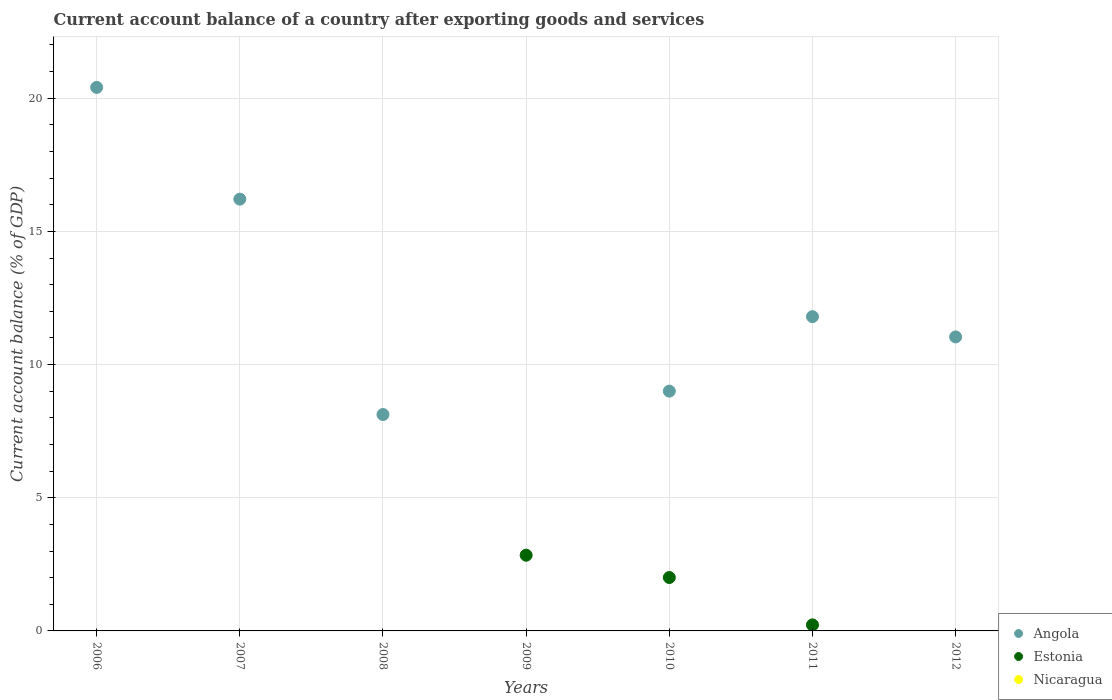Is the number of dotlines equal to the number of legend labels?
Your answer should be very brief. No. What is the account balance in Estonia in 2009?
Your answer should be compact. 2.84. Across all years, what is the maximum account balance in Estonia?
Keep it short and to the point. 2.84. Across all years, what is the minimum account balance in Nicaragua?
Offer a very short reply. 0. In which year was the account balance in Estonia maximum?
Ensure brevity in your answer.  2009. What is the total account balance in Angola in the graph?
Your answer should be very brief. 76.59. What is the difference between the account balance in Angola in 2007 and that in 2008?
Provide a succinct answer. 8.09. What is the difference between the account balance in Nicaragua in 2007 and the account balance in Estonia in 2012?
Keep it short and to the point. 0. What is the average account balance in Estonia per year?
Provide a succinct answer. 0.72. In the year 2011, what is the difference between the account balance in Estonia and account balance in Angola?
Offer a very short reply. -11.57. What is the ratio of the account balance in Estonia in 2009 to that in 2010?
Make the answer very short. 1.42. Is the account balance in Estonia in 2009 less than that in 2011?
Provide a succinct answer. No. What is the difference between the highest and the second highest account balance in Estonia?
Provide a short and direct response. 0.84. What is the difference between the highest and the lowest account balance in Estonia?
Your response must be concise. 2.84. Is the sum of the account balance in Angola in 2007 and 2010 greater than the maximum account balance in Estonia across all years?
Make the answer very short. Yes. Is it the case that in every year, the sum of the account balance in Nicaragua and account balance in Angola  is greater than the account balance in Estonia?
Keep it short and to the point. No. Is the account balance in Estonia strictly greater than the account balance in Nicaragua over the years?
Make the answer very short. No. Is the account balance in Estonia strictly less than the account balance in Angola over the years?
Give a very brief answer. No. What is the difference between two consecutive major ticks on the Y-axis?
Your response must be concise. 5. Does the graph contain any zero values?
Offer a terse response. Yes. Where does the legend appear in the graph?
Provide a succinct answer. Bottom right. How many legend labels are there?
Ensure brevity in your answer.  3. How are the legend labels stacked?
Provide a succinct answer. Vertical. What is the title of the graph?
Your answer should be compact. Current account balance of a country after exporting goods and services. Does "Gambia, The" appear as one of the legend labels in the graph?
Make the answer very short. No. What is the label or title of the Y-axis?
Keep it short and to the point. Current account balance (% of GDP). What is the Current account balance (% of GDP) of Angola in 2006?
Give a very brief answer. 20.41. What is the Current account balance (% of GDP) of Nicaragua in 2006?
Your response must be concise. 0. What is the Current account balance (% of GDP) in Angola in 2007?
Your answer should be compact. 16.21. What is the Current account balance (% of GDP) in Estonia in 2007?
Offer a very short reply. 0. What is the Current account balance (% of GDP) in Nicaragua in 2007?
Your answer should be very brief. 0. What is the Current account balance (% of GDP) in Angola in 2008?
Keep it short and to the point. 8.13. What is the Current account balance (% of GDP) in Estonia in 2008?
Give a very brief answer. 0. What is the Current account balance (% of GDP) in Estonia in 2009?
Provide a succinct answer. 2.84. What is the Current account balance (% of GDP) in Angola in 2010?
Your answer should be compact. 9. What is the Current account balance (% of GDP) of Estonia in 2010?
Your answer should be compact. 2.01. What is the Current account balance (% of GDP) in Angola in 2011?
Make the answer very short. 11.8. What is the Current account balance (% of GDP) in Estonia in 2011?
Make the answer very short. 0.23. What is the Current account balance (% of GDP) of Angola in 2012?
Provide a succinct answer. 11.04. What is the Current account balance (% of GDP) in Estonia in 2012?
Your answer should be very brief. 0. Across all years, what is the maximum Current account balance (% of GDP) in Angola?
Your answer should be very brief. 20.41. Across all years, what is the maximum Current account balance (% of GDP) of Estonia?
Your response must be concise. 2.84. Across all years, what is the minimum Current account balance (% of GDP) in Estonia?
Keep it short and to the point. 0. What is the total Current account balance (% of GDP) of Angola in the graph?
Provide a short and direct response. 76.59. What is the total Current account balance (% of GDP) of Estonia in the graph?
Offer a very short reply. 5.07. What is the difference between the Current account balance (% of GDP) in Angola in 2006 and that in 2007?
Provide a succinct answer. 4.2. What is the difference between the Current account balance (% of GDP) in Angola in 2006 and that in 2008?
Give a very brief answer. 12.28. What is the difference between the Current account balance (% of GDP) in Angola in 2006 and that in 2010?
Your response must be concise. 11.4. What is the difference between the Current account balance (% of GDP) in Angola in 2006 and that in 2011?
Offer a terse response. 8.61. What is the difference between the Current account balance (% of GDP) of Angola in 2006 and that in 2012?
Keep it short and to the point. 9.37. What is the difference between the Current account balance (% of GDP) in Angola in 2007 and that in 2008?
Offer a terse response. 8.09. What is the difference between the Current account balance (% of GDP) of Angola in 2007 and that in 2010?
Your answer should be compact. 7.21. What is the difference between the Current account balance (% of GDP) in Angola in 2007 and that in 2011?
Offer a terse response. 4.41. What is the difference between the Current account balance (% of GDP) in Angola in 2007 and that in 2012?
Ensure brevity in your answer.  5.17. What is the difference between the Current account balance (% of GDP) of Angola in 2008 and that in 2010?
Make the answer very short. -0.88. What is the difference between the Current account balance (% of GDP) in Angola in 2008 and that in 2011?
Provide a succinct answer. -3.67. What is the difference between the Current account balance (% of GDP) of Angola in 2008 and that in 2012?
Provide a succinct answer. -2.91. What is the difference between the Current account balance (% of GDP) in Estonia in 2009 and that in 2010?
Provide a short and direct response. 0.84. What is the difference between the Current account balance (% of GDP) in Estonia in 2009 and that in 2011?
Your answer should be very brief. 2.62. What is the difference between the Current account balance (% of GDP) of Angola in 2010 and that in 2011?
Your answer should be compact. -2.8. What is the difference between the Current account balance (% of GDP) in Estonia in 2010 and that in 2011?
Ensure brevity in your answer.  1.78. What is the difference between the Current account balance (% of GDP) of Angola in 2010 and that in 2012?
Your answer should be very brief. -2.04. What is the difference between the Current account balance (% of GDP) in Angola in 2011 and that in 2012?
Offer a terse response. 0.76. What is the difference between the Current account balance (% of GDP) in Angola in 2006 and the Current account balance (% of GDP) in Estonia in 2009?
Make the answer very short. 17.57. What is the difference between the Current account balance (% of GDP) of Angola in 2006 and the Current account balance (% of GDP) of Estonia in 2010?
Your answer should be very brief. 18.4. What is the difference between the Current account balance (% of GDP) in Angola in 2006 and the Current account balance (% of GDP) in Estonia in 2011?
Offer a very short reply. 20.18. What is the difference between the Current account balance (% of GDP) in Angola in 2007 and the Current account balance (% of GDP) in Estonia in 2009?
Your response must be concise. 13.37. What is the difference between the Current account balance (% of GDP) of Angola in 2007 and the Current account balance (% of GDP) of Estonia in 2010?
Provide a short and direct response. 14.21. What is the difference between the Current account balance (% of GDP) in Angola in 2007 and the Current account balance (% of GDP) in Estonia in 2011?
Provide a succinct answer. 15.99. What is the difference between the Current account balance (% of GDP) of Angola in 2008 and the Current account balance (% of GDP) of Estonia in 2009?
Your response must be concise. 5.28. What is the difference between the Current account balance (% of GDP) in Angola in 2008 and the Current account balance (% of GDP) in Estonia in 2010?
Give a very brief answer. 6.12. What is the difference between the Current account balance (% of GDP) of Angola in 2008 and the Current account balance (% of GDP) of Estonia in 2011?
Provide a short and direct response. 7.9. What is the difference between the Current account balance (% of GDP) in Angola in 2010 and the Current account balance (% of GDP) in Estonia in 2011?
Offer a terse response. 8.78. What is the average Current account balance (% of GDP) of Angola per year?
Ensure brevity in your answer.  10.94. What is the average Current account balance (% of GDP) of Estonia per year?
Provide a short and direct response. 0.72. In the year 2010, what is the difference between the Current account balance (% of GDP) of Angola and Current account balance (% of GDP) of Estonia?
Your response must be concise. 7. In the year 2011, what is the difference between the Current account balance (% of GDP) in Angola and Current account balance (% of GDP) in Estonia?
Your answer should be very brief. 11.57. What is the ratio of the Current account balance (% of GDP) of Angola in 2006 to that in 2007?
Your response must be concise. 1.26. What is the ratio of the Current account balance (% of GDP) of Angola in 2006 to that in 2008?
Offer a very short reply. 2.51. What is the ratio of the Current account balance (% of GDP) in Angola in 2006 to that in 2010?
Keep it short and to the point. 2.27. What is the ratio of the Current account balance (% of GDP) in Angola in 2006 to that in 2011?
Give a very brief answer. 1.73. What is the ratio of the Current account balance (% of GDP) in Angola in 2006 to that in 2012?
Provide a short and direct response. 1.85. What is the ratio of the Current account balance (% of GDP) in Angola in 2007 to that in 2008?
Offer a terse response. 2. What is the ratio of the Current account balance (% of GDP) in Angola in 2007 to that in 2010?
Offer a very short reply. 1.8. What is the ratio of the Current account balance (% of GDP) in Angola in 2007 to that in 2011?
Make the answer very short. 1.37. What is the ratio of the Current account balance (% of GDP) in Angola in 2007 to that in 2012?
Offer a terse response. 1.47. What is the ratio of the Current account balance (% of GDP) of Angola in 2008 to that in 2010?
Your answer should be very brief. 0.9. What is the ratio of the Current account balance (% of GDP) in Angola in 2008 to that in 2011?
Your response must be concise. 0.69. What is the ratio of the Current account balance (% of GDP) of Angola in 2008 to that in 2012?
Give a very brief answer. 0.74. What is the ratio of the Current account balance (% of GDP) in Estonia in 2009 to that in 2010?
Keep it short and to the point. 1.42. What is the ratio of the Current account balance (% of GDP) in Estonia in 2009 to that in 2011?
Offer a very short reply. 12.53. What is the ratio of the Current account balance (% of GDP) in Angola in 2010 to that in 2011?
Give a very brief answer. 0.76. What is the ratio of the Current account balance (% of GDP) in Estonia in 2010 to that in 2011?
Provide a short and direct response. 8.84. What is the ratio of the Current account balance (% of GDP) of Angola in 2010 to that in 2012?
Your answer should be very brief. 0.82. What is the ratio of the Current account balance (% of GDP) in Angola in 2011 to that in 2012?
Your answer should be compact. 1.07. What is the difference between the highest and the second highest Current account balance (% of GDP) in Angola?
Your answer should be very brief. 4.2. What is the difference between the highest and the second highest Current account balance (% of GDP) of Estonia?
Make the answer very short. 0.84. What is the difference between the highest and the lowest Current account balance (% of GDP) of Angola?
Your answer should be compact. 20.41. What is the difference between the highest and the lowest Current account balance (% of GDP) in Estonia?
Your answer should be very brief. 2.84. 